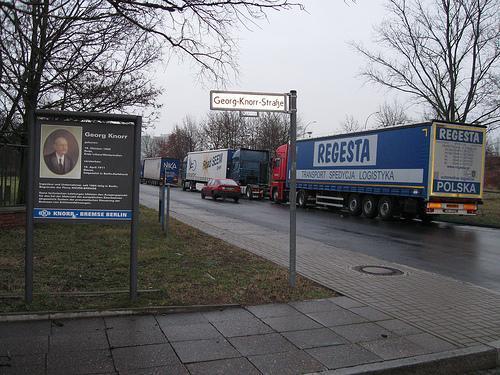How many vehicles are visible?
Give a very brief answer. 5. 